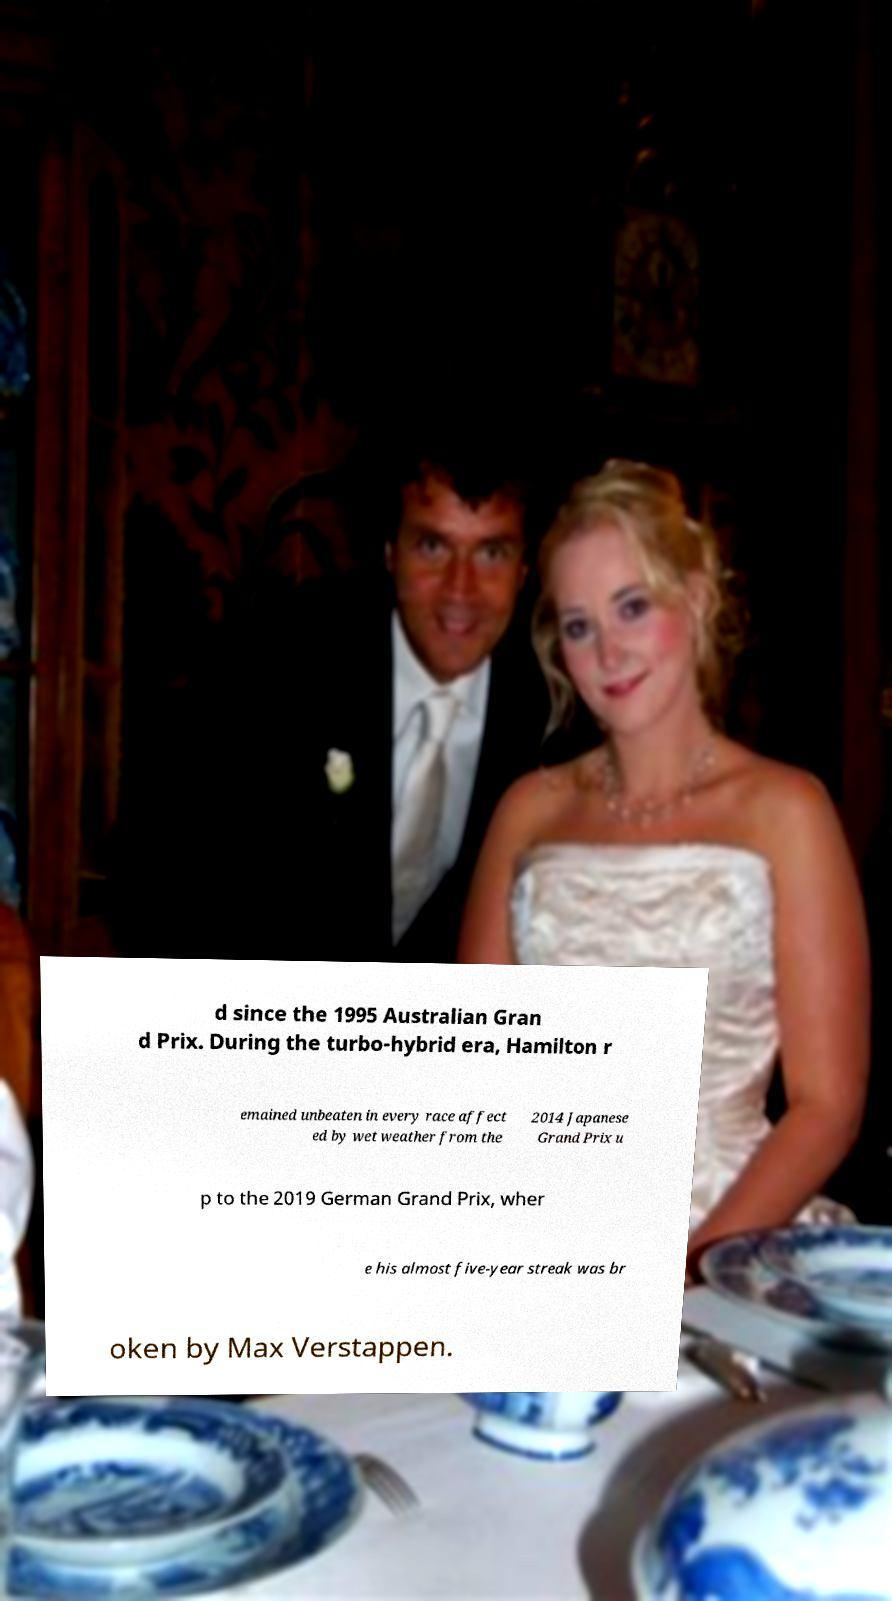What messages or text are displayed in this image? I need them in a readable, typed format. d since the 1995 Australian Gran d Prix. During the turbo-hybrid era, Hamilton r emained unbeaten in every race affect ed by wet weather from the 2014 Japanese Grand Prix u p to the 2019 German Grand Prix, wher e his almost five-year streak was br oken by Max Verstappen. 